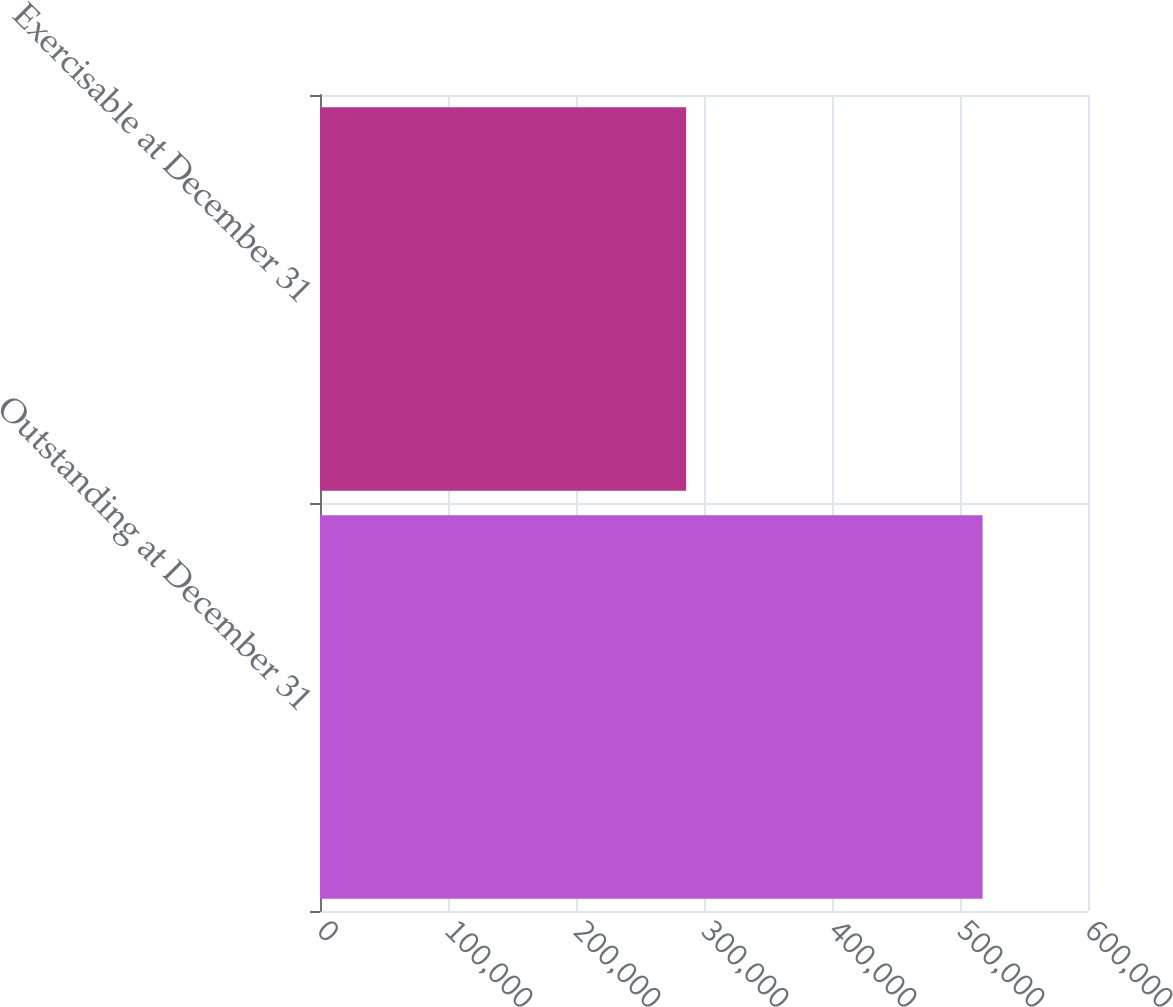Convert chart. <chart><loc_0><loc_0><loc_500><loc_500><bar_chart><fcel>Outstanding at December 31<fcel>Exercisable at December 31<nl><fcel>517653<fcel>286054<nl></chart> 